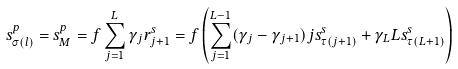Convert formula to latex. <formula><loc_0><loc_0><loc_500><loc_500>s _ { \sigma ( l ) } ^ { p } = s _ { M } ^ { p } = f \sum _ { j = 1 } ^ { L } \gamma _ { j } r _ { j + 1 } ^ { s } = f \left ( \sum _ { j = 1 } ^ { L - 1 } ( \gamma _ { j } - \gamma _ { j + 1 } ) j s _ { \tau ( j + 1 ) } ^ { s } + \gamma _ { L } L s _ { \tau ( L + 1 ) } ^ { s } \right )</formula> 